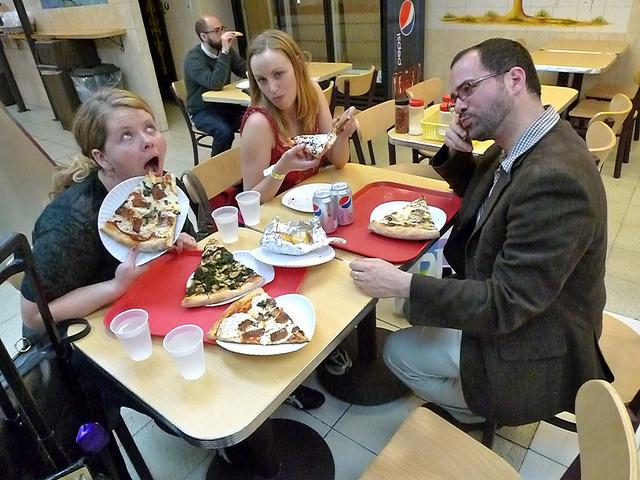What is the girl eating?
Answer briefly. Pizza. What food are they eating?
Keep it brief. Pizza. What color is the trays?
Quick response, please. Red. What kind of soda are the people drinking?
Answer briefly. Pepsi. Are the people eating with chopsticks?
Give a very brief answer. No. How many people are in the picture?
Quick response, please. 4. 